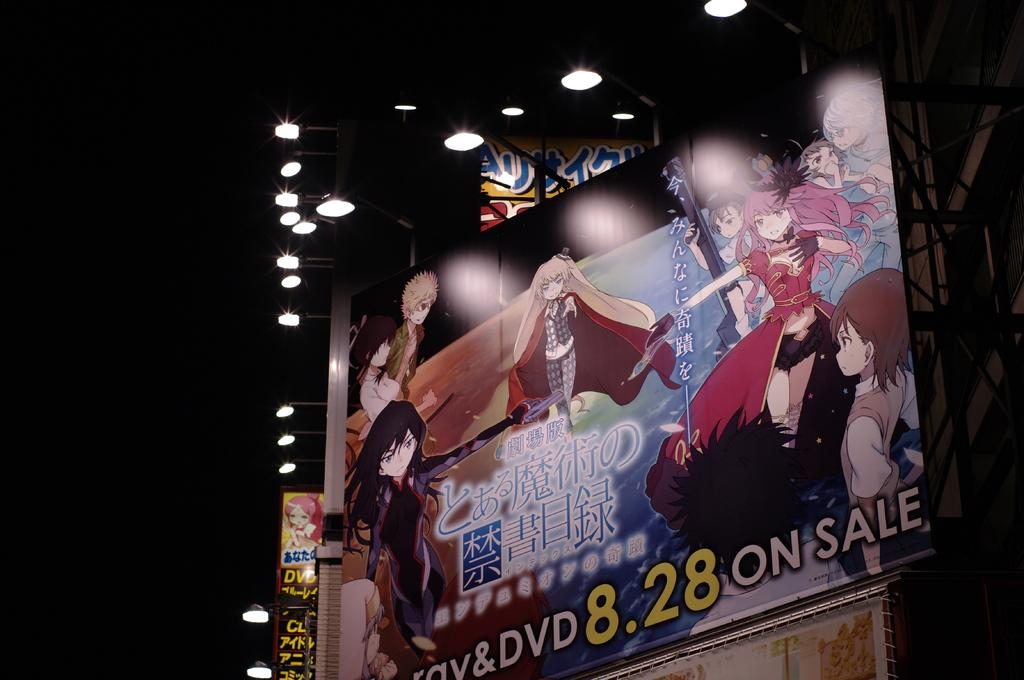What is the main subject of the image? The main subject of the image is a hoarding. What can be seen on the hoarding? The hoarding has a depiction of people and text. What else is visible in the image besides the hoarding? There are lights, the sky, and rods on the right side of the image. Can you tell me how many aunts are depicted on the hoarding? There are no aunts depicted on the hoarding; it features a depiction of people in general. What type of basin is visible in the image? There is no basin present in the image. 